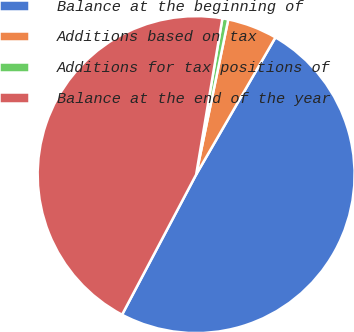<chart> <loc_0><loc_0><loc_500><loc_500><pie_chart><fcel>Balance at the beginning of<fcel>Additions based on tax<fcel>Additions for tax positions of<fcel>Balance at the end of the year<nl><fcel>49.4%<fcel>5.09%<fcel>0.6%<fcel>44.91%<nl></chart> 